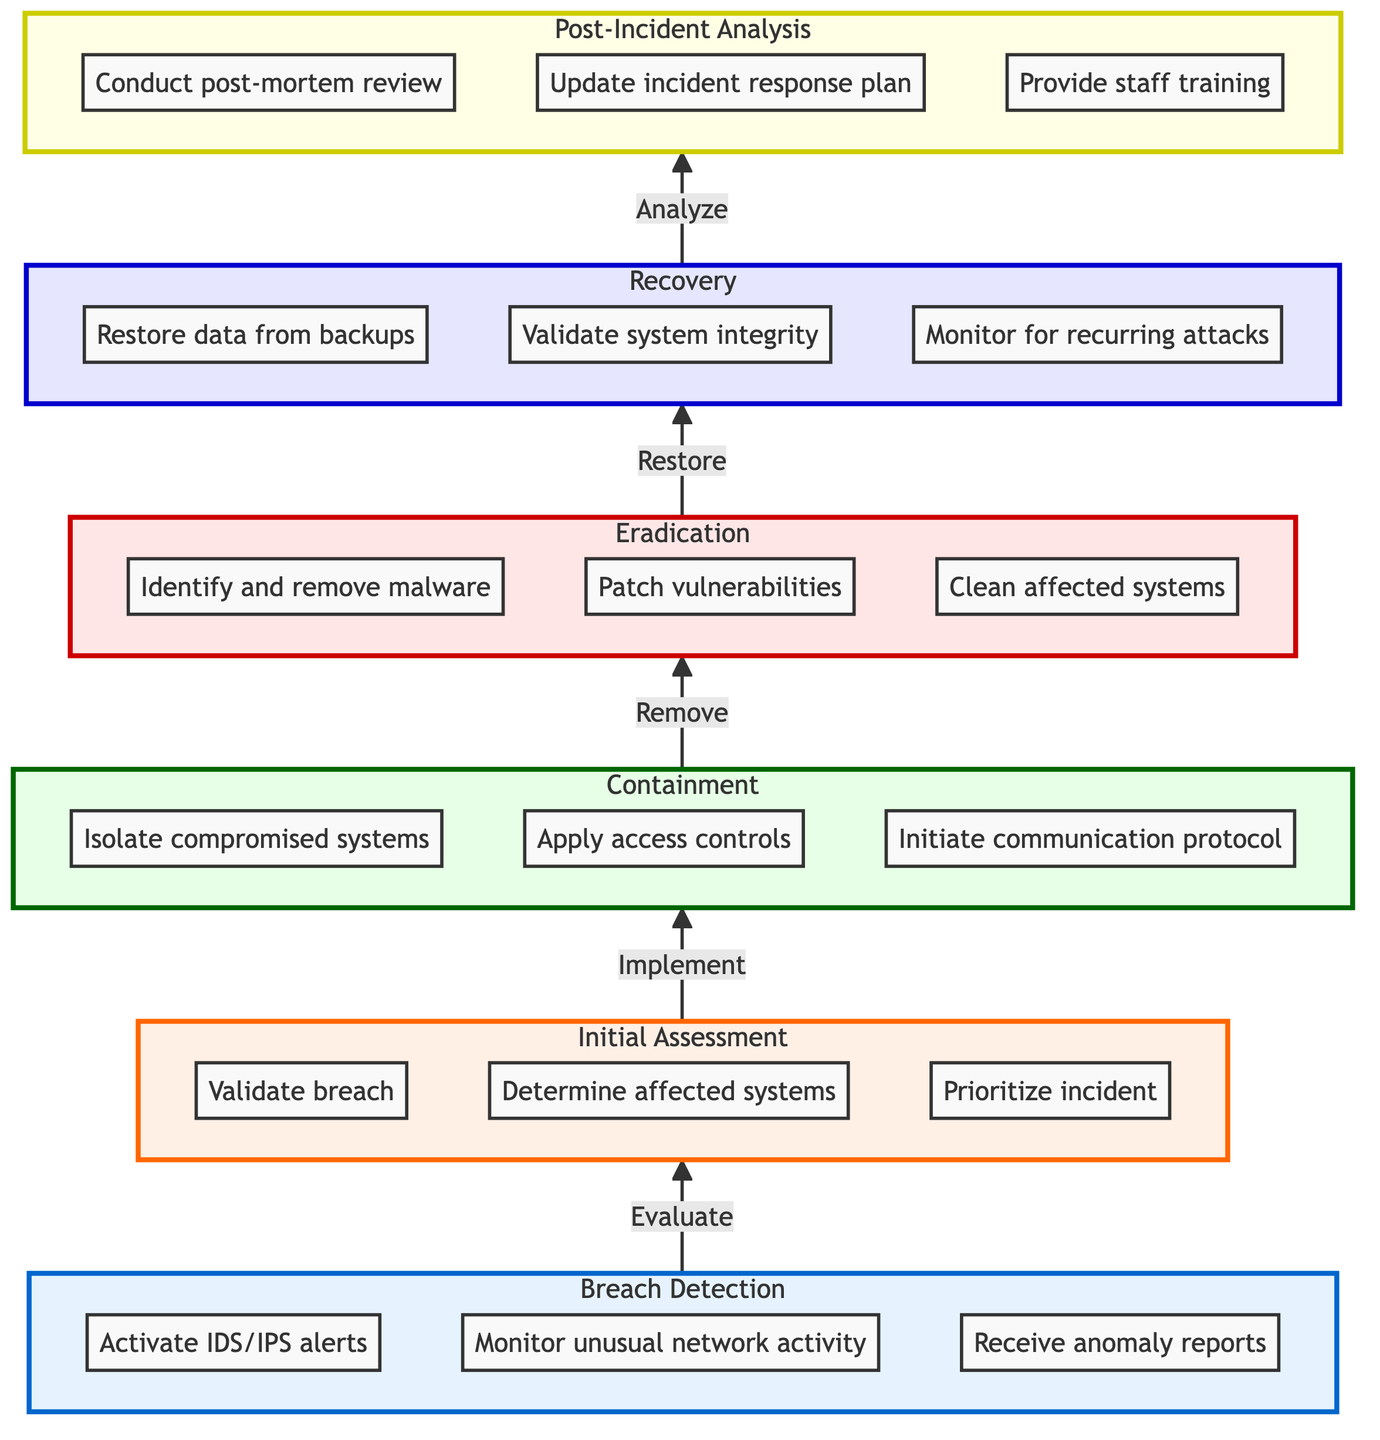What is the first step in the incident response workflow? The first step in the workflow is 'Breach Detection,' as indicated at the bottom of the flow chart. It represents the starting point for the incident response process.
Answer: Breach Detection How many total steps are there in the incident response workflow? Counting from 'Breach Detection' at the bottom to 'Post-Incident Analysis' at the top, there are a total of 6 steps in the workflow.
Answer: 6 Which node comes after the 'Containment' step? The step that follows 'Containment' is 'Eradication,' as indicated by the arrow leading upwards. This means after containing the incident, the next action is to eradicate the issue.
Answer: Eradication What action occurs during the 'Recovery' step? During the 'Recovery' step, the action taken is to 'Restore data from backups,' which is one of the actions listed in that node.
Answer: Restore data from backups Who is responsible for the 'Initial Assessment'? The responsibilities for the 'Initial Assessment' are listed as the 'Incident Response Team' and 'Cryptologist.' Thus, both parties share the responsibility for this step.
Answer: Incident Response Team, Cryptologist What is the main focus of the 'Post-Incident Analysis'? The main focus of 'Post-Incident Analysis' is to analyze the incident and improve future response, which involves conducting a review and updating plans.
Answer: Analyze incident, improve future response Which actions must be taken in 'Eradication'? In the 'Eradication' step, the necessary actions include 'Identify and remove malware,' 'Patch vulnerabilities,' and 'Clean affected systems.' All these actions aim to eliminate the cause of the breach.
Answer: Identify and remove malware, Patch vulnerabilities, Clean affected systems How does the role of a Cryptologist vary in the process? The role of the 'Cryptologist' appears in the 'Initial Assessment,' 'Containment,' and 'Post-Incident Analysis' steps, indicating that their involvement is critical at various stages of the incident response process.
Answer: Initial Assessment, Containment, Post-Incident Analysis What is the relationship between 'Recovery' and 'Post-Incident Analysis'? The relationship is that 'Recovery' leads directly to 'Post-Incident Analysis,' indicated by the upward arrow connecting these two nodes. This suggests that once recovery is achieved, analysis follows next.
Answer: Recovery leads to Post-Incident Analysis 